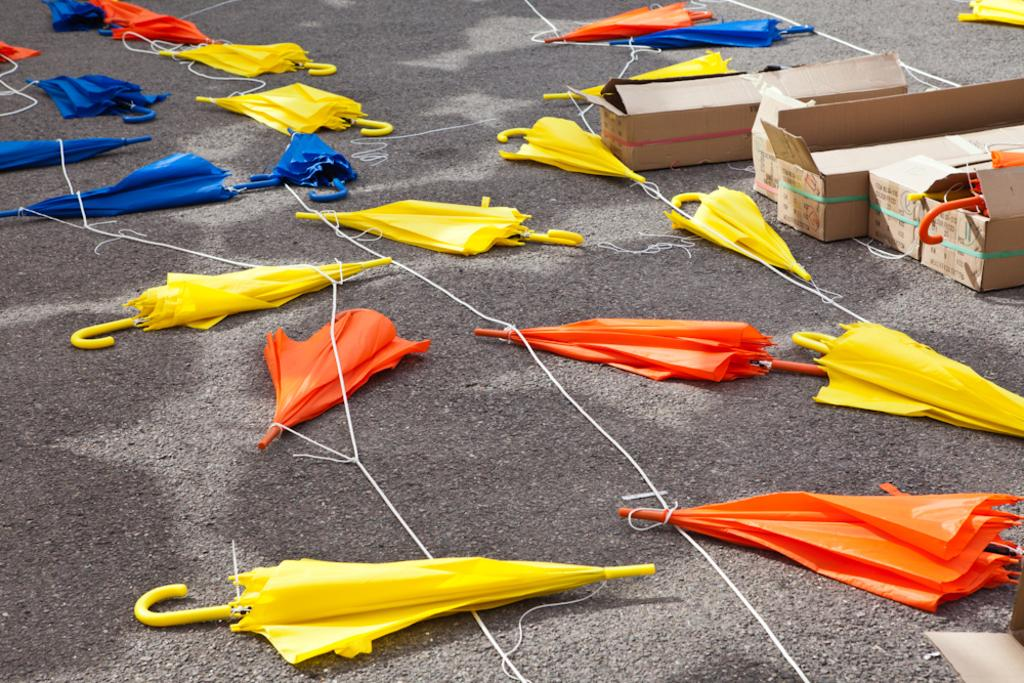What can be seen tied to a rope on the road in the image? There are umbrellas tied to a rope on the road in the image. What is located on the right side of the image? There are cardboard boxes on the right side of the image. What is inside the cardboard boxes? The cardboard boxes contain umbrellas. Can you describe the maid standing next to the cardboard boxes in the image? There is no maid present in the image; it only features umbrellas tied to a rope on the road and cardboard boxes containing umbrellas on the right side. What type of creature can be seen interacting with the umbrellas in the image? There is no creature present in the image; it only features umbrellas tied to a rope on the road and cardboard boxes containing umbrellas on the right side. 